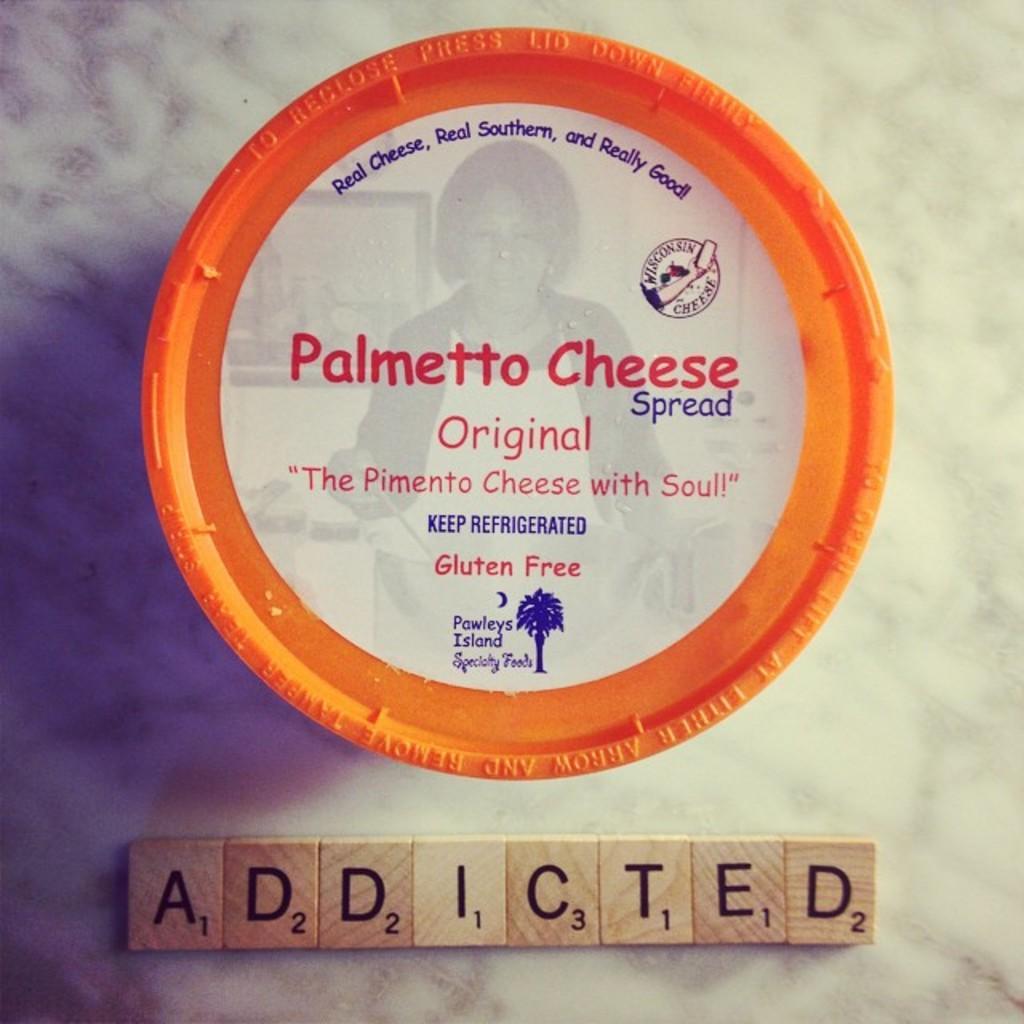How would you summarize this image in a sentence or two? In this image we can see a plate on which some text is printed and in the background ,we can see group of wood blocks with text on it. 